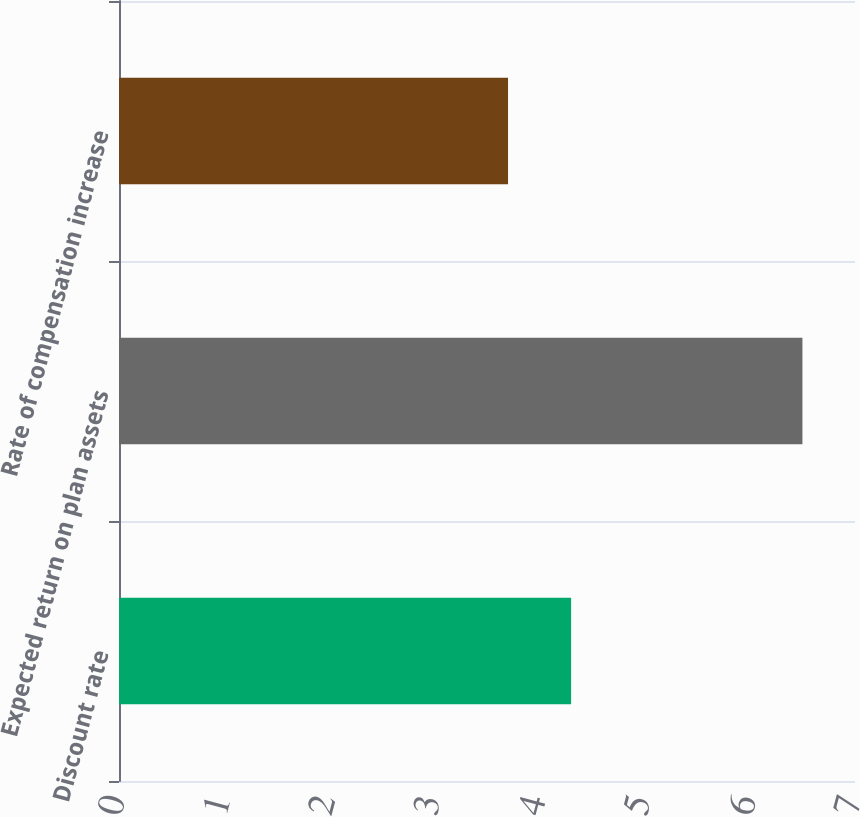Convert chart. <chart><loc_0><loc_0><loc_500><loc_500><bar_chart><fcel>Discount rate<fcel>Expected return on plan assets<fcel>Rate of compensation increase<nl><fcel>4.3<fcel>6.5<fcel>3.7<nl></chart> 